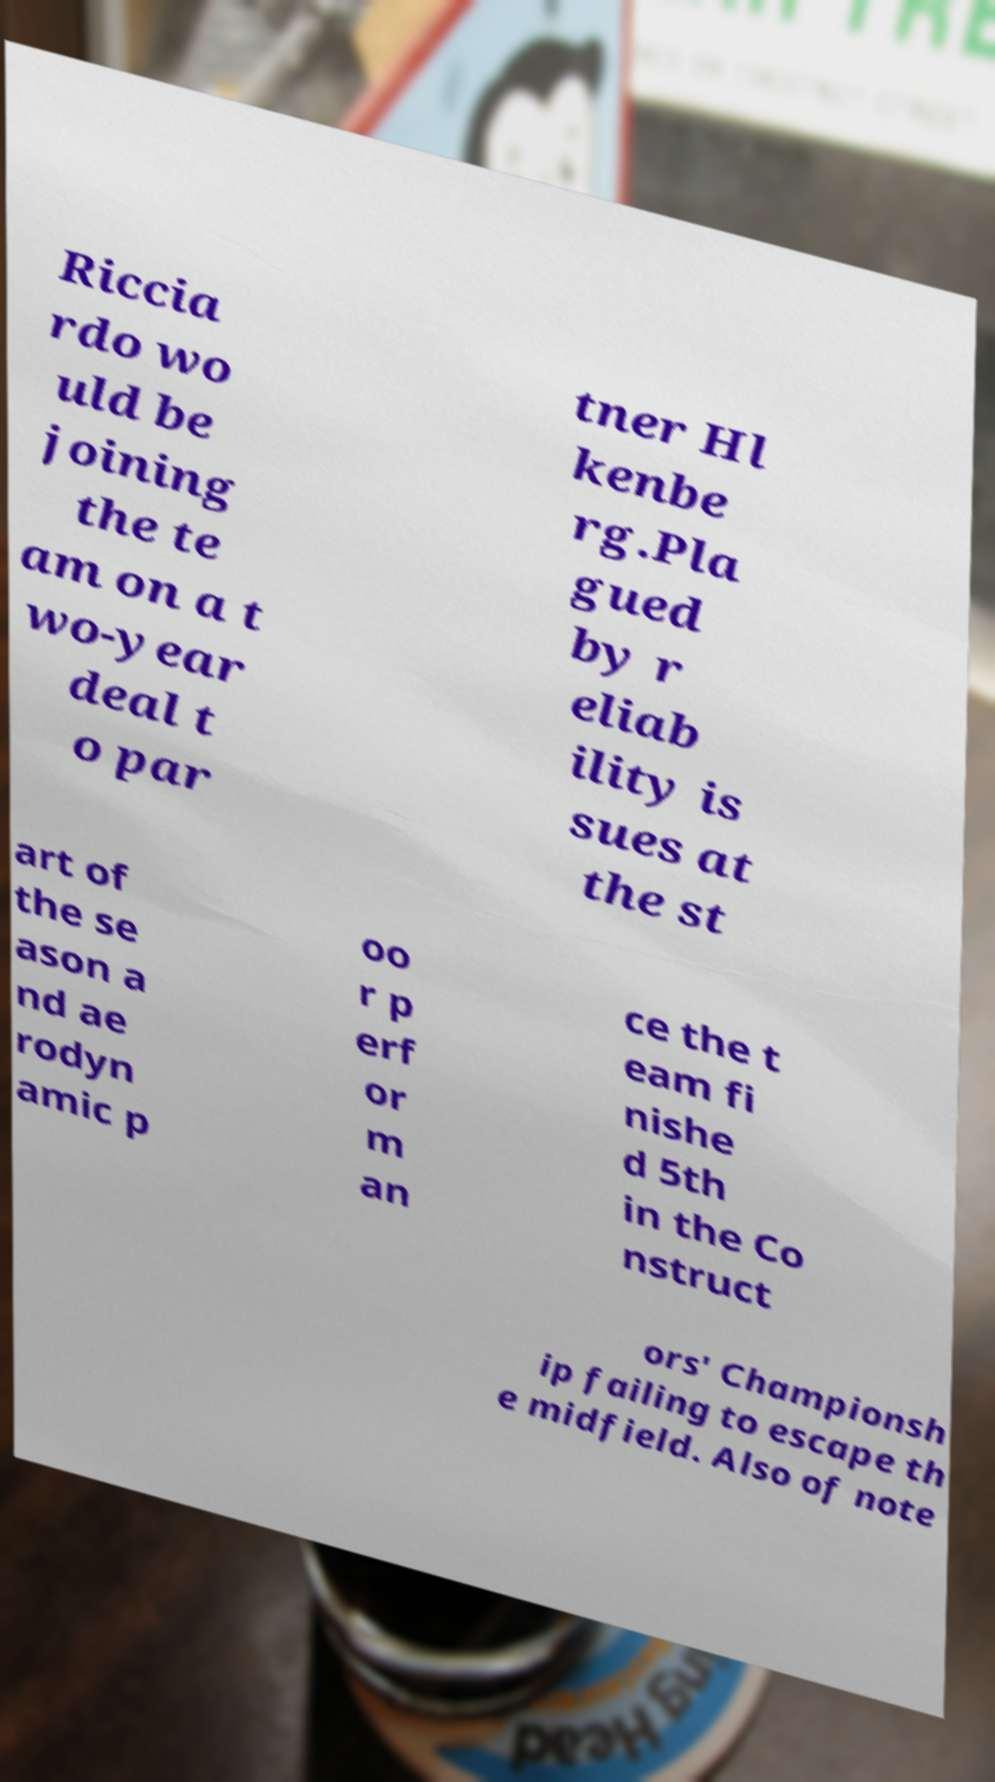Could you extract and type out the text from this image? Riccia rdo wo uld be joining the te am on a t wo-year deal t o par tner Hl kenbe rg.Pla gued by r eliab ility is sues at the st art of the se ason a nd ae rodyn amic p oo r p erf or m an ce the t eam fi nishe d 5th in the Co nstruct ors' Championsh ip failing to escape th e midfield. Also of note 